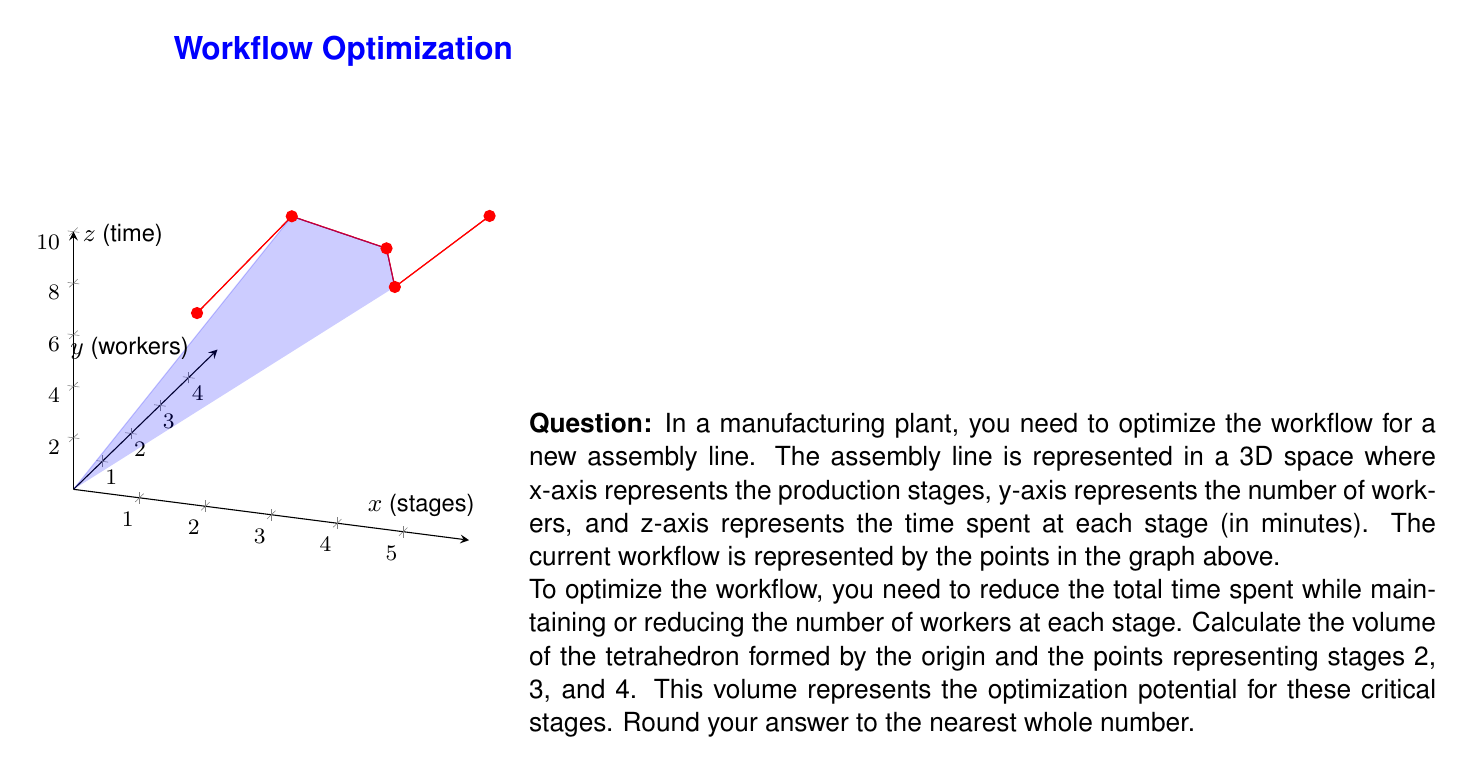Give your solution to this math problem. Let's approach this step-by-step:

1) The points representing stages 2, 3, and 4 are:
   A(2, 3, 8), B(3, 4, 6), C(4, 2, 7)

2) To calculate the volume of a tetrahedron, we can use the formula:

   $$V = \frac{1}{6}|det(\vec{a}, \vec{b}, \vec{c})|$$

   where $\vec{a}$, $\vec{b}$, and $\vec{c}$ are vectors from the origin to points A, B, and C respectively.

3) Let's define these vectors:
   $\vec{a} = (2, 3, 8)$
   $\vec{b} = (3, 4, 6)$
   $\vec{c} = (4, 2, 7)$

4) Now we need to calculate the determinant:

   $$det(\vec{a}, \vec{b}, \vec{c}) = \begin{vmatrix} 
   2 & 3 & 4 \\
   3 & 4 & 2 \\
   8 & 6 & 7
   \end{vmatrix}$$

5) Expanding the determinant:

   $$det = 2(4(7) - 2(6)) - 3(3(7) - 4(8)) + 4(3(6) - 4(3))$$
   $$det = 2(28 - 12) - 3(21 - 32) + 4(18 - 12)$$
   $$det = 2(16) - 3(-11) + 4(6)$$
   $$det = 32 + 33 + 24 = 89$$

6) Now we can calculate the volume:

   $$V = \frac{1}{6}|89| = \frac{89}{6} \approx 14.83$$

7) Rounding to the nearest whole number:

   $$V \approx 15$$

This volume represents the optimization potential for stages 2, 3, and 4. A larger volume indicates more room for optimization in terms of reducing time and/or number of workers.
Answer: 15 